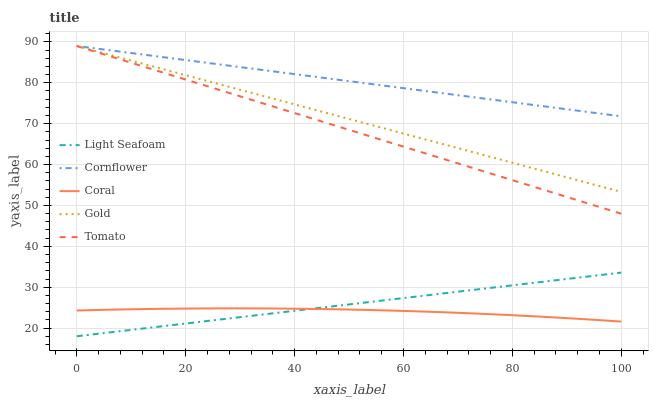Does Coral have the minimum area under the curve?
Answer yes or no. Yes. Does Cornflower have the maximum area under the curve?
Answer yes or no. Yes. Does Cornflower have the minimum area under the curve?
Answer yes or no. No. Does Coral have the maximum area under the curve?
Answer yes or no. No. Is Light Seafoam the smoothest?
Answer yes or no. Yes. Is Coral the roughest?
Answer yes or no. Yes. Is Cornflower the smoothest?
Answer yes or no. No. Is Cornflower the roughest?
Answer yes or no. No. Does Coral have the lowest value?
Answer yes or no. No. Does Gold have the highest value?
Answer yes or no. Yes. Does Coral have the highest value?
Answer yes or no. No. Is Coral less than Cornflower?
Answer yes or no. Yes. Is Tomato greater than Light Seafoam?
Answer yes or no. Yes. Does Gold intersect Cornflower?
Answer yes or no. Yes. Is Gold less than Cornflower?
Answer yes or no. No. Is Gold greater than Cornflower?
Answer yes or no. No. Does Coral intersect Cornflower?
Answer yes or no. No. 